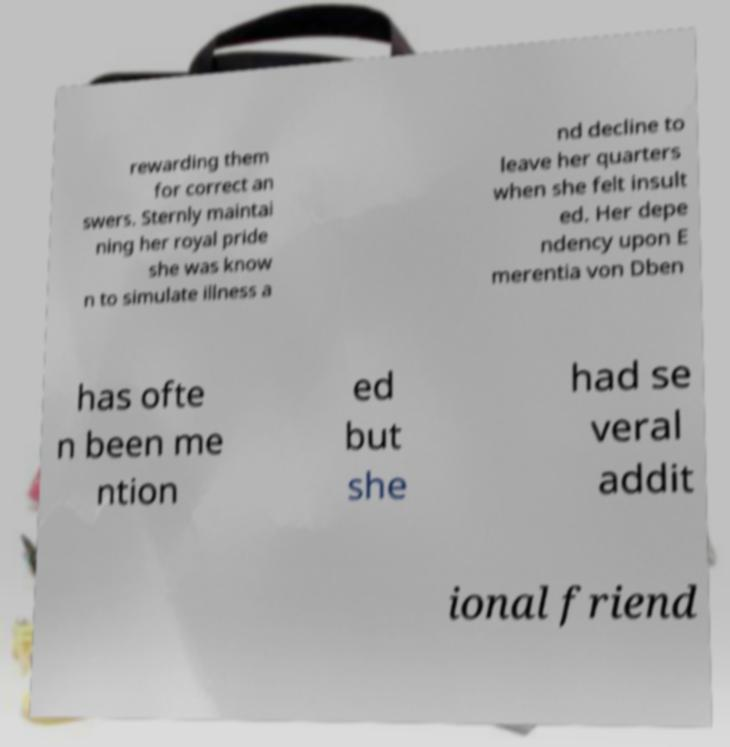Could you extract and type out the text from this image? rewarding them for correct an swers. Sternly maintai ning her royal pride she was know n to simulate illness a nd decline to leave her quarters when she felt insult ed. Her depe ndency upon E merentia von Dben has ofte n been me ntion ed but she had se veral addit ional friend 